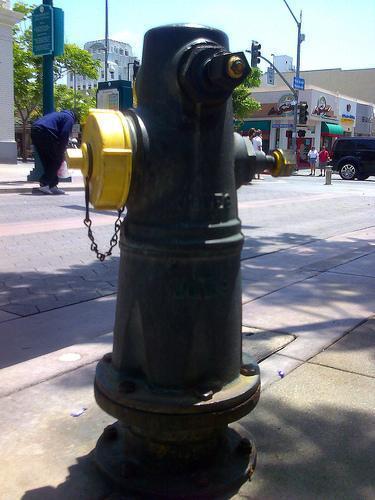How many cars are in this picture?
Give a very brief answer. 1. How many traffic lights are there?
Give a very brief answer. 1. 